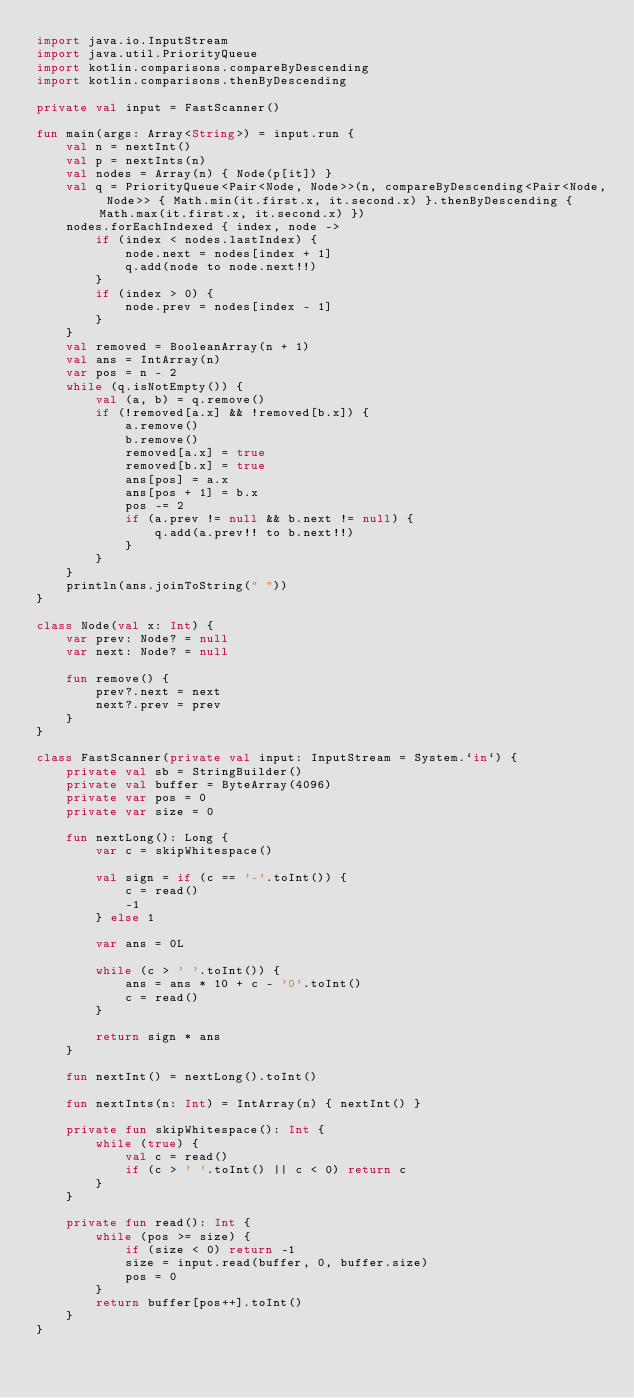Convert code to text. <code><loc_0><loc_0><loc_500><loc_500><_Kotlin_>import java.io.InputStream
import java.util.PriorityQueue
import kotlin.comparisons.compareByDescending
import kotlin.comparisons.thenByDescending

private val input = FastScanner()

fun main(args: Array<String>) = input.run {
    val n = nextInt()
    val p = nextInts(n)
    val nodes = Array(n) { Node(p[it]) }
    val q = PriorityQueue<Pair<Node, Node>>(n, compareByDescending<Pair<Node, Node>> { Math.min(it.first.x, it.second.x) }.thenByDescending { Math.max(it.first.x, it.second.x) })
    nodes.forEachIndexed { index, node ->
        if (index < nodes.lastIndex) {
            node.next = nodes[index + 1]
            q.add(node to node.next!!)
        }
        if (index > 0) {
            node.prev = nodes[index - 1]
        }
    }
    val removed = BooleanArray(n + 1)
    val ans = IntArray(n)
    var pos = n - 2
    while (q.isNotEmpty()) {
        val (a, b) = q.remove()
        if (!removed[a.x] && !removed[b.x]) {
            a.remove()
            b.remove()
            removed[a.x] = true
            removed[b.x] = true
            ans[pos] = a.x
            ans[pos + 1] = b.x
            pos -= 2
            if (a.prev != null && b.next != null) {
                q.add(a.prev!! to b.next!!)
            }
        }
    }
    println(ans.joinToString(" "))
}

class Node(val x: Int) {
    var prev: Node? = null
    var next: Node? = null

    fun remove() {
        prev?.next = next
        next?.prev = prev
    }
}

class FastScanner(private val input: InputStream = System.`in`) {
    private val sb = StringBuilder()
    private val buffer = ByteArray(4096)
    private var pos = 0
    private var size = 0

    fun nextLong(): Long {
        var c = skipWhitespace()

        val sign = if (c == '-'.toInt()) {
            c = read()
            -1
        } else 1

        var ans = 0L

        while (c > ' '.toInt()) {
            ans = ans * 10 + c - '0'.toInt()
            c = read()
        }

        return sign * ans
    }

    fun nextInt() = nextLong().toInt()

    fun nextInts(n: Int) = IntArray(n) { nextInt() }

    private fun skipWhitespace(): Int {
        while (true) {
            val c = read()
            if (c > ' '.toInt() || c < 0) return c
        }
    }

    private fun read(): Int {
        while (pos >= size) {
            if (size < 0) return -1
            size = input.read(buffer, 0, buffer.size)
            pos = 0
        }
        return buffer[pos++].toInt()
    }
}</code> 